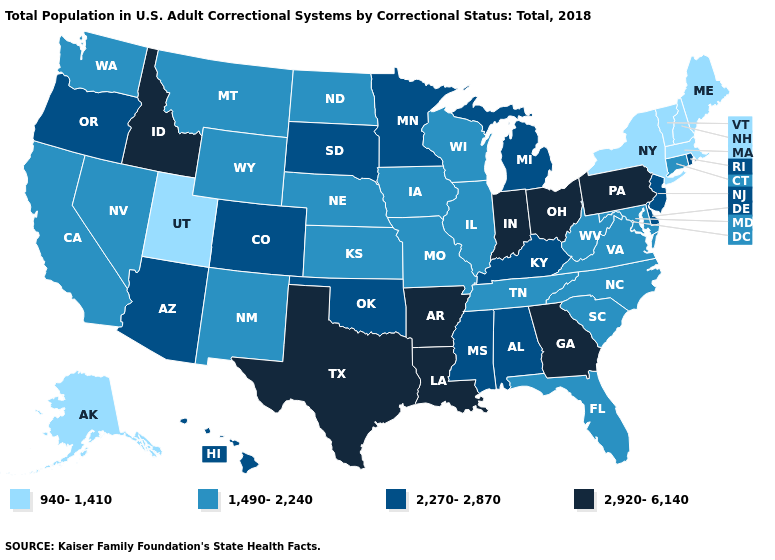Name the states that have a value in the range 1,490-2,240?
Answer briefly. California, Connecticut, Florida, Illinois, Iowa, Kansas, Maryland, Missouri, Montana, Nebraska, Nevada, New Mexico, North Carolina, North Dakota, South Carolina, Tennessee, Virginia, Washington, West Virginia, Wisconsin, Wyoming. What is the lowest value in the MidWest?
Write a very short answer. 1,490-2,240. Does Colorado have a higher value than Wisconsin?
Give a very brief answer. Yes. What is the value of Arkansas?
Give a very brief answer. 2,920-6,140. What is the value of Nevada?
Write a very short answer. 1,490-2,240. Name the states that have a value in the range 2,920-6,140?
Keep it brief. Arkansas, Georgia, Idaho, Indiana, Louisiana, Ohio, Pennsylvania, Texas. Is the legend a continuous bar?
Give a very brief answer. No. What is the value of Vermont?
Give a very brief answer. 940-1,410. Name the states that have a value in the range 2,270-2,870?
Short answer required. Alabama, Arizona, Colorado, Delaware, Hawaii, Kentucky, Michigan, Minnesota, Mississippi, New Jersey, Oklahoma, Oregon, Rhode Island, South Dakota. What is the value of Rhode Island?
Write a very short answer. 2,270-2,870. Does Massachusetts have the lowest value in the USA?
Concise answer only. Yes. What is the highest value in the USA?
Keep it brief. 2,920-6,140. What is the value of Louisiana?
Write a very short answer. 2,920-6,140. Which states have the highest value in the USA?
Write a very short answer. Arkansas, Georgia, Idaho, Indiana, Louisiana, Ohio, Pennsylvania, Texas. What is the value of Ohio?
Write a very short answer. 2,920-6,140. 